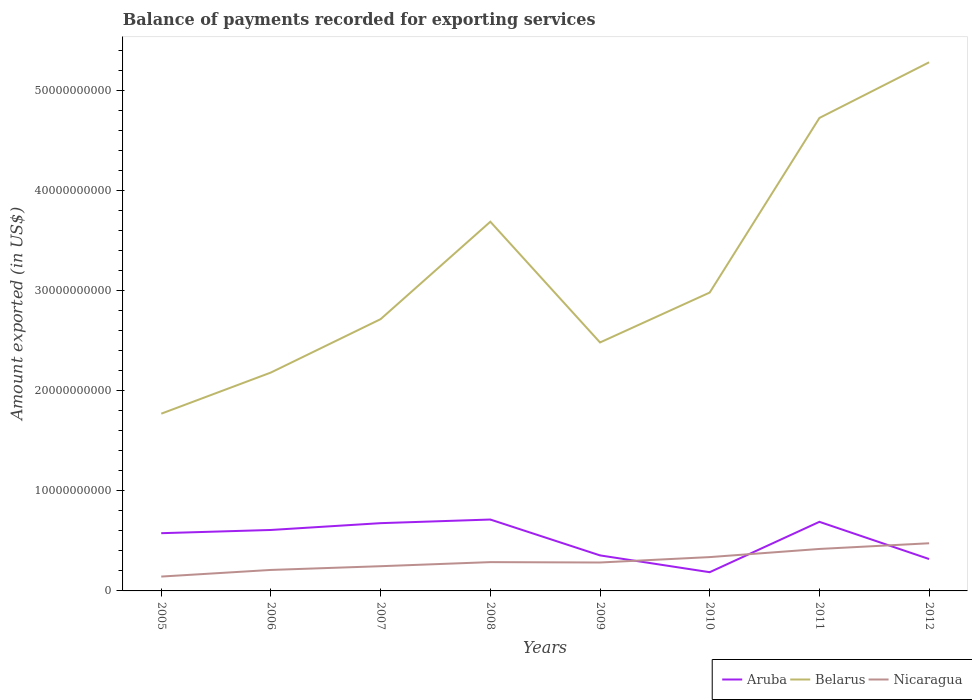How many different coloured lines are there?
Provide a short and direct response. 3. Does the line corresponding to Aruba intersect with the line corresponding to Nicaragua?
Ensure brevity in your answer.  Yes. Across all years, what is the maximum amount exported in Aruba?
Offer a terse response. 1.87e+09. What is the total amount exported in Nicaragua in the graph?
Offer a terse response. -1.35e+09. What is the difference between the highest and the second highest amount exported in Belarus?
Provide a short and direct response. 3.51e+1. What is the difference between the highest and the lowest amount exported in Nicaragua?
Ensure brevity in your answer.  3. How many years are there in the graph?
Provide a short and direct response. 8. Are the values on the major ticks of Y-axis written in scientific E-notation?
Keep it short and to the point. No. Does the graph contain any zero values?
Offer a very short reply. No. Does the graph contain grids?
Offer a very short reply. No. How are the legend labels stacked?
Ensure brevity in your answer.  Horizontal. What is the title of the graph?
Your response must be concise. Balance of payments recorded for exporting services. What is the label or title of the X-axis?
Your response must be concise. Years. What is the label or title of the Y-axis?
Your answer should be compact. Amount exported (in US$). What is the Amount exported (in US$) of Aruba in 2005?
Your answer should be very brief. 5.77e+09. What is the Amount exported (in US$) of Belarus in 2005?
Make the answer very short. 1.77e+1. What is the Amount exported (in US$) in Nicaragua in 2005?
Make the answer very short. 1.43e+09. What is the Amount exported (in US$) in Aruba in 2006?
Provide a succinct answer. 6.09e+09. What is the Amount exported (in US$) in Belarus in 2006?
Ensure brevity in your answer.  2.18e+1. What is the Amount exported (in US$) in Nicaragua in 2006?
Keep it short and to the point. 2.10e+09. What is the Amount exported (in US$) of Aruba in 2007?
Provide a succinct answer. 6.77e+09. What is the Amount exported (in US$) in Belarus in 2007?
Provide a short and direct response. 2.71e+1. What is the Amount exported (in US$) of Nicaragua in 2007?
Give a very brief answer. 2.47e+09. What is the Amount exported (in US$) of Aruba in 2008?
Ensure brevity in your answer.  7.13e+09. What is the Amount exported (in US$) in Belarus in 2008?
Your response must be concise. 3.69e+1. What is the Amount exported (in US$) in Nicaragua in 2008?
Keep it short and to the point. 2.88e+09. What is the Amount exported (in US$) in Aruba in 2009?
Ensure brevity in your answer.  3.55e+09. What is the Amount exported (in US$) of Belarus in 2009?
Ensure brevity in your answer.  2.48e+1. What is the Amount exported (in US$) in Nicaragua in 2009?
Provide a short and direct response. 2.84e+09. What is the Amount exported (in US$) in Aruba in 2010?
Keep it short and to the point. 1.87e+09. What is the Amount exported (in US$) in Belarus in 2010?
Your answer should be very brief. 2.98e+1. What is the Amount exported (in US$) in Nicaragua in 2010?
Your answer should be compact. 3.38e+09. What is the Amount exported (in US$) in Aruba in 2011?
Your answer should be very brief. 6.90e+09. What is the Amount exported (in US$) in Belarus in 2011?
Provide a short and direct response. 4.72e+1. What is the Amount exported (in US$) in Nicaragua in 2011?
Keep it short and to the point. 4.19e+09. What is the Amount exported (in US$) in Aruba in 2012?
Provide a succinct answer. 3.19e+09. What is the Amount exported (in US$) of Belarus in 2012?
Provide a succinct answer. 5.28e+1. What is the Amount exported (in US$) in Nicaragua in 2012?
Keep it short and to the point. 4.76e+09. Across all years, what is the maximum Amount exported (in US$) in Aruba?
Give a very brief answer. 7.13e+09. Across all years, what is the maximum Amount exported (in US$) in Belarus?
Ensure brevity in your answer.  5.28e+1. Across all years, what is the maximum Amount exported (in US$) of Nicaragua?
Offer a terse response. 4.76e+09. Across all years, what is the minimum Amount exported (in US$) in Aruba?
Give a very brief answer. 1.87e+09. Across all years, what is the minimum Amount exported (in US$) in Belarus?
Offer a very short reply. 1.77e+1. Across all years, what is the minimum Amount exported (in US$) in Nicaragua?
Offer a very short reply. 1.43e+09. What is the total Amount exported (in US$) in Aruba in the graph?
Provide a short and direct response. 4.13e+1. What is the total Amount exported (in US$) in Belarus in the graph?
Keep it short and to the point. 2.58e+11. What is the total Amount exported (in US$) of Nicaragua in the graph?
Your answer should be very brief. 2.40e+1. What is the difference between the Amount exported (in US$) of Aruba in 2005 and that in 2006?
Provide a short and direct response. -3.22e+08. What is the difference between the Amount exported (in US$) in Belarus in 2005 and that in 2006?
Make the answer very short. -4.11e+09. What is the difference between the Amount exported (in US$) in Nicaragua in 2005 and that in 2006?
Offer a terse response. -6.63e+08. What is the difference between the Amount exported (in US$) of Aruba in 2005 and that in 2007?
Your answer should be compact. -1.00e+09. What is the difference between the Amount exported (in US$) of Belarus in 2005 and that in 2007?
Offer a very short reply. -9.44e+09. What is the difference between the Amount exported (in US$) of Nicaragua in 2005 and that in 2007?
Provide a succinct answer. -1.04e+09. What is the difference between the Amount exported (in US$) of Aruba in 2005 and that in 2008?
Make the answer very short. -1.37e+09. What is the difference between the Amount exported (in US$) in Belarus in 2005 and that in 2008?
Provide a succinct answer. -1.92e+1. What is the difference between the Amount exported (in US$) of Nicaragua in 2005 and that in 2008?
Keep it short and to the point. -1.44e+09. What is the difference between the Amount exported (in US$) of Aruba in 2005 and that in 2009?
Give a very brief answer. 2.22e+09. What is the difference between the Amount exported (in US$) of Belarus in 2005 and that in 2009?
Ensure brevity in your answer.  -7.11e+09. What is the difference between the Amount exported (in US$) in Nicaragua in 2005 and that in 2009?
Offer a very short reply. -1.40e+09. What is the difference between the Amount exported (in US$) of Aruba in 2005 and that in 2010?
Provide a short and direct response. 3.90e+09. What is the difference between the Amount exported (in US$) in Belarus in 2005 and that in 2010?
Ensure brevity in your answer.  -1.21e+1. What is the difference between the Amount exported (in US$) in Nicaragua in 2005 and that in 2010?
Your response must be concise. -1.94e+09. What is the difference between the Amount exported (in US$) in Aruba in 2005 and that in 2011?
Make the answer very short. -1.14e+09. What is the difference between the Amount exported (in US$) in Belarus in 2005 and that in 2011?
Provide a short and direct response. -2.95e+1. What is the difference between the Amount exported (in US$) of Nicaragua in 2005 and that in 2011?
Give a very brief answer. -2.76e+09. What is the difference between the Amount exported (in US$) of Aruba in 2005 and that in 2012?
Your answer should be compact. 2.58e+09. What is the difference between the Amount exported (in US$) in Belarus in 2005 and that in 2012?
Offer a very short reply. -3.51e+1. What is the difference between the Amount exported (in US$) of Nicaragua in 2005 and that in 2012?
Make the answer very short. -3.33e+09. What is the difference between the Amount exported (in US$) of Aruba in 2006 and that in 2007?
Your answer should be very brief. -6.80e+08. What is the difference between the Amount exported (in US$) in Belarus in 2006 and that in 2007?
Keep it short and to the point. -5.33e+09. What is the difference between the Amount exported (in US$) of Nicaragua in 2006 and that in 2007?
Ensure brevity in your answer.  -3.72e+08. What is the difference between the Amount exported (in US$) of Aruba in 2006 and that in 2008?
Keep it short and to the point. -1.04e+09. What is the difference between the Amount exported (in US$) of Belarus in 2006 and that in 2008?
Provide a short and direct response. -1.51e+1. What is the difference between the Amount exported (in US$) of Nicaragua in 2006 and that in 2008?
Provide a short and direct response. -7.79e+08. What is the difference between the Amount exported (in US$) of Aruba in 2006 and that in 2009?
Provide a short and direct response. 2.54e+09. What is the difference between the Amount exported (in US$) of Belarus in 2006 and that in 2009?
Provide a short and direct response. -3.00e+09. What is the difference between the Amount exported (in US$) in Nicaragua in 2006 and that in 2009?
Your answer should be very brief. -7.42e+08. What is the difference between the Amount exported (in US$) of Aruba in 2006 and that in 2010?
Keep it short and to the point. 4.22e+09. What is the difference between the Amount exported (in US$) in Belarus in 2006 and that in 2010?
Give a very brief answer. -7.99e+09. What is the difference between the Amount exported (in US$) of Nicaragua in 2006 and that in 2010?
Provide a succinct answer. -1.28e+09. What is the difference between the Amount exported (in US$) in Aruba in 2006 and that in 2011?
Make the answer very short. -8.13e+08. What is the difference between the Amount exported (in US$) in Belarus in 2006 and that in 2011?
Offer a terse response. -2.54e+1. What is the difference between the Amount exported (in US$) in Nicaragua in 2006 and that in 2011?
Give a very brief answer. -2.09e+09. What is the difference between the Amount exported (in US$) of Aruba in 2006 and that in 2012?
Your response must be concise. 2.90e+09. What is the difference between the Amount exported (in US$) of Belarus in 2006 and that in 2012?
Your response must be concise. -3.10e+1. What is the difference between the Amount exported (in US$) in Nicaragua in 2006 and that in 2012?
Keep it short and to the point. -2.66e+09. What is the difference between the Amount exported (in US$) in Aruba in 2007 and that in 2008?
Keep it short and to the point. -3.63e+08. What is the difference between the Amount exported (in US$) in Belarus in 2007 and that in 2008?
Give a very brief answer. -9.73e+09. What is the difference between the Amount exported (in US$) in Nicaragua in 2007 and that in 2008?
Ensure brevity in your answer.  -4.07e+08. What is the difference between the Amount exported (in US$) of Aruba in 2007 and that in 2009?
Make the answer very short. 3.22e+09. What is the difference between the Amount exported (in US$) of Belarus in 2007 and that in 2009?
Your answer should be very brief. 2.33e+09. What is the difference between the Amount exported (in US$) of Nicaragua in 2007 and that in 2009?
Keep it short and to the point. -3.69e+08. What is the difference between the Amount exported (in US$) of Aruba in 2007 and that in 2010?
Your response must be concise. 4.90e+09. What is the difference between the Amount exported (in US$) of Belarus in 2007 and that in 2010?
Your response must be concise. -2.66e+09. What is the difference between the Amount exported (in US$) of Nicaragua in 2007 and that in 2010?
Provide a short and direct response. -9.09e+08. What is the difference between the Amount exported (in US$) in Aruba in 2007 and that in 2011?
Provide a short and direct response. -1.33e+08. What is the difference between the Amount exported (in US$) in Belarus in 2007 and that in 2011?
Make the answer very short. -2.01e+1. What is the difference between the Amount exported (in US$) of Nicaragua in 2007 and that in 2011?
Provide a succinct answer. -1.72e+09. What is the difference between the Amount exported (in US$) in Aruba in 2007 and that in 2012?
Provide a short and direct response. 3.58e+09. What is the difference between the Amount exported (in US$) of Belarus in 2007 and that in 2012?
Your answer should be very brief. -2.57e+1. What is the difference between the Amount exported (in US$) in Nicaragua in 2007 and that in 2012?
Offer a terse response. -2.29e+09. What is the difference between the Amount exported (in US$) in Aruba in 2008 and that in 2009?
Ensure brevity in your answer.  3.58e+09. What is the difference between the Amount exported (in US$) in Belarus in 2008 and that in 2009?
Ensure brevity in your answer.  1.21e+1. What is the difference between the Amount exported (in US$) of Nicaragua in 2008 and that in 2009?
Give a very brief answer. 3.75e+07. What is the difference between the Amount exported (in US$) of Aruba in 2008 and that in 2010?
Make the answer very short. 5.26e+09. What is the difference between the Amount exported (in US$) of Belarus in 2008 and that in 2010?
Offer a very short reply. 7.07e+09. What is the difference between the Amount exported (in US$) in Nicaragua in 2008 and that in 2010?
Your response must be concise. -5.02e+08. What is the difference between the Amount exported (in US$) in Aruba in 2008 and that in 2011?
Provide a succinct answer. 2.30e+08. What is the difference between the Amount exported (in US$) of Belarus in 2008 and that in 2011?
Offer a very short reply. -1.04e+1. What is the difference between the Amount exported (in US$) of Nicaragua in 2008 and that in 2011?
Provide a succinct answer. -1.32e+09. What is the difference between the Amount exported (in US$) in Aruba in 2008 and that in 2012?
Give a very brief answer. 3.95e+09. What is the difference between the Amount exported (in US$) of Belarus in 2008 and that in 2012?
Make the answer very short. -1.59e+1. What is the difference between the Amount exported (in US$) of Nicaragua in 2008 and that in 2012?
Your answer should be very brief. -1.88e+09. What is the difference between the Amount exported (in US$) in Aruba in 2009 and that in 2010?
Offer a very short reply. 1.68e+09. What is the difference between the Amount exported (in US$) in Belarus in 2009 and that in 2010?
Your response must be concise. -4.99e+09. What is the difference between the Amount exported (in US$) in Nicaragua in 2009 and that in 2010?
Your answer should be compact. -5.40e+08. What is the difference between the Amount exported (in US$) in Aruba in 2009 and that in 2011?
Your answer should be very brief. -3.35e+09. What is the difference between the Amount exported (in US$) of Belarus in 2009 and that in 2011?
Offer a very short reply. -2.24e+1. What is the difference between the Amount exported (in US$) in Nicaragua in 2009 and that in 2011?
Your answer should be very brief. -1.35e+09. What is the difference between the Amount exported (in US$) of Aruba in 2009 and that in 2012?
Your answer should be compact. 3.63e+08. What is the difference between the Amount exported (in US$) of Belarus in 2009 and that in 2012?
Keep it short and to the point. -2.80e+1. What is the difference between the Amount exported (in US$) of Nicaragua in 2009 and that in 2012?
Your response must be concise. -1.92e+09. What is the difference between the Amount exported (in US$) of Aruba in 2010 and that in 2011?
Give a very brief answer. -5.03e+09. What is the difference between the Amount exported (in US$) in Belarus in 2010 and that in 2011?
Provide a succinct answer. -1.74e+1. What is the difference between the Amount exported (in US$) of Nicaragua in 2010 and that in 2011?
Provide a succinct answer. -8.13e+08. What is the difference between the Amount exported (in US$) of Aruba in 2010 and that in 2012?
Keep it short and to the point. -1.32e+09. What is the difference between the Amount exported (in US$) in Belarus in 2010 and that in 2012?
Ensure brevity in your answer.  -2.30e+1. What is the difference between the Amount exported (in US$) in Nicaragua in 2010 and that in 2012?
Give a very brief answer. -1.38e+09. What is the difference between the Amount exported (in US$) in Aruba in 2011 and that in 2012?
Offer a terse response. 3.72e+09. What is the difference between the Amount exported (in US$) of Belarus in 2011 and that in 2012?
Your response must be concise. -5.56e+09. What is the difference between the Amount exported (in US$) in Nicaragua in 2011 and that in 2012?
Offer a very short reply. -5.69e+08. What is the difference between the Amount exported (in US$) of Aruba in 2005 and the Amount exported (in US$) of Belarus in 2006?
Your answer should be very brief. -1.60e+1. What is the difference between the Amount exported (in US$) in Aruba in 2005 and the Amount exported (in US$) in Nicaragua in 2006?
Your response must be concise. 3.67e+09. What is the difference between the Amount exported (in US$) of Belarus in 2005 and the Amount exported (in US$) of Nicaragua in 2006?
Your response must be concise. 1.56e+1. What is the difference between the Amount exported (in US$) of Aruba in 2005 and the Amount exported (in US$) of Belarus in 2007?
Make the answer very short. -2.14e+1. What is the difference between the Amount exported (in US$) in Aruba in 2005 and the Amount exported (in US$) in Nicaragua in 2007?
Your answer should be compact. 3.30e+09. What is the difference between the Amount exported (in US$) of Belarus in 2005 and the Amount exported (in US$) of Nicaragua in 2007?
Give a very brief answer. 1.52e+1. What is the difference between the Amount exported (in US$) in Aruba in 2005 and the Amount exported (in US$) in Belarus in 2008?
Your answer should be compact. -3.11e+1. What is the difference between the Amount exported (in US$) of Aruba in 2005 and the Amount exported (in US$) of Nicaragua in 2008?
Provide a succinct answer. 2.89e+09. What is the difference between the Amount exported (in US$) of Belarus in 2005 and the Amount exported (in US$) of Nicaragua in 2008?
Your answer should be very brief. 1.48e+1. What is the difference between the Amount exported (in US$) in Aruba in 2005 and the Amount exported (in US$) in Belarus in 2009?
Provide a short and direct response. -1.91e+1. What is the difference between the Amount exported (in US$) of Aruba in 2005 and the Amount exported (in US$) of Nicaragua in 2009?
Your response must be concise. 2.93e+09. What is the difference between the Amount exported (in US$) of Belarus in 2005 and the Amount exported (in US$) of Nicaragua in 2009?
Your answer should be compact. 1.49e+1. What is the difference between the Amount exported (in US$) of Aruba in 2005 and the Amount exported (in US$) of Belarus in 2010?
Offer a very short reply. -2.40e+1. What is the difference between the Amount exported (in US$) in Aruba in 2005 and the Amount exported (in US$) in Nicaragua in 2010?
Your response must be concise. 2.39e+09. What is the difference between the Amount exported (in US$) of Belarus in 2005 and the Amount exported (in US$) of Nicaragua in 2010?
Keep it short and to the point. 1.43e+1. What is the difference between the Amount exported (in US$) of Aruba in 2005 and the Amount exported (in US$) of Belarus in 2011?
Provide a succinct answer. -4.15e+1. What is the difference between the Amount exported (in US$) in Aruba in 2005 and the Amount exported (in US$) in Nicaragua in 2011?
Your response must be concise. 1.57e+09. What is the difference between the Amount exported (in US$) of Belarus in 2005 and the Amount exported (in US$) of Nicaragua in 2011?
Provide a short and direct response. 1.35e+1. What is the difference between the Amount exported (in US$) of Aruba in 2005 and the Amount exported (in US$) of Belarus in 2012?
Ensure brevity in your answer.  -4.70e+1. What is the difference between the Amount exported (in US$) of Aruba in 2005 and the Amount exported (in US$) of Nicaragua in 2012?
Provide a short and direct response. 1.01e+09. What is the difference between the Amount exported (in US$) in Belarus in 2005 and the Amount exported (in US$) in Nicaragua in 2012?
Give a very brief answer. 1.29e+1. What is the difference between the Amount exported (in US$) in Aruba in 2006 and the Amount exported (in US$) in Belarus in 2007?
Ensure brevity in your answer.  -2.11e+1. What is the difference between the Amount exported (in US$) in Aruba in 2006 and the Amount exported (in US$) in Nicaragua in 2007?
Offer a terse response. 3.62e+09. What is the difference between the Amount exported (in US$) of Belarus in 2006 and the Amount exported (in US$) of Nicaragua in 2007?
Your response must be concise. 1.93e+1. What is the difference between the Amount exported (in US$) of Aruba in 2006 and the Amount exported (in US$) of Belarus in 2008?
Keep it short and to the point. -3.08e+1. What is the difference between the Amount exported (in US$) in Aruba in 2006 and the Amount exported (in US$) in Nicaragua in 2008?
Make the answer very short. 3.21e+09. What is the difference between the Amount exported (in US$) of Belarus in 2006 and the Amount exported (in US$) of Nicaragua in 2008?
Offer a terse response. 1.89e+1. What is the difference between the Amount exported (in US$) of Aruba in 2006 and the Amount exported (in US$) of Belarus in 2009?
Keep it short and to the point. -1.87e+1. What is the difference between the Amount exported (in US$) of Aruba in 2006 and the Amount exported (in US$) of Nicaragua in 2009?
Your answer should be very brief. 3.25e+09. What is the difference between the Amount exported (in US$) of Belarus in 2006 and the Amount exported (in US$) of Nicaragua in 2009?
Offer a terse response. 1.90e+1. What is the difference between the Amount exported (in US$) of Aruba in 2006 and the Amount exported (in US$) of Belarus in 2010?
Make the answer very short. -2.37e+1. What is the difference between the Amount exported (in US$) of Aruba in 2006 and the Amount exported (in US$) of Nicaragua in 2010?
Your answer should be very brief. 2.71e+09. What is the difference between the Amount exported (in US$) of Belarus in 2006 and the Amount exported (in US$) of Nicaragua in 2010?
Offer a terse response. 1.84e+1. What is the difference between the Amount exported (in US$) of Aruba in 2006 and the Amount exported (in US$) of Belarus in 2011?
Provide a short and direct response. -4.12e+1. What is the difference between the Amount exported (in US$) in Aruba in 2006 and the Amount exported (in US$) in Nicaragua in 2011?
Ensure brevity in your answer.  1.90e+09. What is the difference between the Amount exported (in US$) of Belarus in 2006 and the Amount exported (in US$) of Nicaragua in 2011?
Your answer should be very brief. 1.76e+1. What is the difference between the Amount exported (in US$) of Aruba in 2006 and the Amount exported (in US$) of Belarus in 2012?
Ensure brevity in your answer.  -4.67e+1. What is the difference between the Amount exported (in US$) of Aruba in 2006 and the Amount exported (in US$) of Nicaragua in 2012?
Offer a terse response. 1.33e+09. What is the difference between the Amount exported (in US$) in Belarus in 2006 and the Amount exported (in US$) in Nicaragua in 2012?
Offer a very short reply. 1.71e+1. What is the difference between the Amount exported (in US$) in Aruba in 2007 and the Amount exported (in US$) in Belarus in 2008?
Make the answer very short. -3.01e+1. What is the difference between the Amount exported (in US$) of Aruba in 2007 and the Amount exported (in US$) of Nicaragua in 2008?
Offer a very short reply. 3.89e+09. What is the difference between the Amount exported (in US$) in Belarus in 2007 and the Amount exported (in US$) in Nicaragua in 2008?
Make the answer very short. 2.43e+1. What is the difference between the Amount exported (in US$) of Aruba in 2007 and the Amount exported (in US$) of Belarus in 2009?
Keep it short and to the point. -1.80e+1. What is the difference between the Amount exported (in US$) in Aruba in 2007 and the Amount exported (in US$) in Nicaragua in 2009?
Provide a short and direct response. 3.93e+09. What is the difference between the Amount exported (in US$) of Belarus in 2007 and the Amount exported (in US$) of Nicaragua in 2009?
Keep it short and to the point. 2.43e+1. What is the difference between the Amount exported (in US$) in Aruba in 2007 and the Amount exported (in US$) in Belarus in 2010?
Provide a short and direct response. -2.30e+1. What is the difference between the Amount exported (in US$) of Aruba in 2007 and the Amount exported (in US$) of Nicaragua in 2010?
Ensure brevity in your answer.  3.39e+09. What is the difference between the Amount exported (in US$) of Belarus in 2007 and the Amount exported (in US$) of Nicaragua in 2010?
Keep it short and to the point. 2.38e+1. What is the difference between the Amount exported (in US$) of Aruba in 2007 and the Amount exported (in US$) of Belarus in 2011?
Your answer should be compact. -4.05e+1. What is the difference between the Amount exported (in US$) of Aruba in 2007 and the Amount exported (in US$) of Nicaragua in 2011?
Offer a very short reply. 2.58e+09. What is the difference between the Amount exported (in US$) in Belarus in 2007 and the Amount exported (in US$) in Nicaragua in 2011?
Make the answer very short. 2.30e+1. What is the difference between the Amount exported (in US$) of Aruba in 2007 and the Amount exported (in US$) of Belarus in 2012?
Offer a very short reply. -4.60e+1. What is the difference between the Amount exported (in US$) of Aruba in 2007 and the Amount exported (in US$) of Nicaragua in 2012?
Give a very brief answer. 2.01e+09. What is the difference between the Amount exported (in US$) in Belarus in 2007 and the Amount exported (in US$) in Nicaragua in 2012?
Provide a short and direct response. 2.24e+1. What is the difference between the Amount exported (in US$) in Aruba in 2008 and the Amount exported (in US$) in Belarus in 2009?
Make the answer very short. -1.77e+1. What is the difference between the Amount exported (in US$) in Aruba in 2008 and the Amount exported (in US$) in Nicaragua in 2009?
Give a very brief answer. 4.29e+09. What is the difference between the Amount exported (in US$) of Belarus in 2008 and the Amount exported (in US$) of Nicaragua in 2009?
Keep it short and to the point. 3.40e+1. What is the difference between the Amount exported (in US$) of Aruba in 2008 and the Amount exported (in US$) of Belarus in 2010?
Provide a short and direct response. -2.27e+1. What is the difference between the Amount exported (in US$) in Aruba in 2008 and the Amount exported (in US$) in Nicaragua in 2010?
Give a very brief answer. 3.75e+09. What is the difference between the Amount exported (in US$) of Belarus in 2008 and the Amount exported (in US$) of Nicaragua in 2010?
Offer a terse response. 3.35e+1. What is the difference between the Amount exported (in US$) of Aruba in 2008 and the Amount exported (in US$) of Belarus in 2011?
Make the answer very short. -4.01e+1. What is the difference between the Amount exported (in US$) of Aruba in 2008 and the Amount exported (in US$) of Nicaragua in 2011?
Make the answer very short. 2.94e+09. What is the difference between the Amount exported (in US$) of Belarus in 2008 and the Amount exported (in US$) of Nicaragua in 2011?
Your answer should be compact. 3.27e+1. What is the difference between the Amount exported (in US$) in Aruba in 2008 and the Amount exported (in US$) in Belarus in 2012?
Keep it short and to the point. -4.57e+1. What is the difference between the Amount exported (in US$) of Aruba in 2008 and the Amount exported (in US$) of Nicaragua in 2012?
Provide a short and direct response. 2.37e+09. What is the difference between the Amount exported (in US$) in Belarus in 2008 and the Amount exported (in US$) in Nicaragua in 2012?
Your response must be concise. 3.21e+1. What is the difference between the Amount exported (in US$) in Aruba in 2009 and the Amount exported (in US$) in Belarus in 2010?
Provide a succinct answer. -2.63e+1. What is the difference between the Amount exported (in US$) of Aruba in 2009 and the Amount exported (in US$) of Nicaragua in 2010?
Provide a short and direct response. 1.71e+08. What is the difference between the Amount exported (in US$) of Belarus in 2009 and the Amount exported (in US$) of Nicaragua in 2010?
Offer a terse response. 2.14e+1. What is the difference between the Amount exported (in US$) of Aruba in 2009 and the Amount exported (in US$) of Belarus in 2011?
Provide a succinct answer. -4.37e+1. What is the difference between the Amount exported (in US$) of Aruba in 2009 and the Amount exported (in US$) of Nicaragua in 2011?
Your answer should be very brief. -6.42e+08. What is the difference between the Amount exported (in US$) in Belarus in 2009 and the Amount exported (in US$) in Nicaragua in 2011?
Your answer should be very brief. 2.06e+1. What is the difference between the Amount exported (in US$) in Aruba in 2009 and the Amount exported (in US$) in Belarus in 2012?
Make the answer very short. -4.93e+1. What is the difference between the Amount exported (in US$) in Aruba in 2009 and the Amount exported (in US$) in Nicaragua in 2012?
Provide a succinct answer. -1.21e+09. What is the difference between the Amount exported (in US$) in Belarus in 2009 and the Amount exported (in US$) in Nicaragua in 2012?
Provide a succinct answer. 2.01e+1. What is the difference between the Amount exported (in US$) of Aruba in 2010 and the Amount exported (in US$) of Belarus in 2011?
Offer a terse response. -4.54e+1. What is the difference between the Amount exported (in US$) of Aruba in 2010 and the Amount exported (in US$) of Nicaragua in 2011?
Give a very brief answer. -2.32e+09. What is the difference between the Amount exported (in US$) of Belarus in 2010 and the Amount exported (in US$) of Nicaragua in 2011?
Keep it short and to the point. 2.56e+1. What is the difference between the Amount exported (in US$) of Aruba in 2010 and the Amount exported (in US$) of Belarus in 2012?
Keep it short and to the point. -5.09e+1. What is the difference between the Amount exported (in US$) in Aruba in 2010 and the Amount exported (in US$) in Nicaragua in 2012?
Ensure brevity in your answer.  -2.89e+09. What is the difference between the Amount exported (in US$) of Belarus in 2010 and the Amount exported (in US$) of Nicaragua in 2012?
Your answer should be compact. 2.50e+1. What is the difference between the Amount exported (in US$) in Aruba in 2011 and the Amount exported (in US$) in Belarus in 2012?
Keep it short and to the point. -4.59e+1. What is the difference between the Amount exported (in US$) of Aruba in 2011 and the Amount exported (in US$) of Nicaragua in 2012?
Provide a short and direct response. 2.14e+09. What is the difference between the Amount exported (in US$) in Belarus in 2011 and the Amount exported (in US$) in Nicaragua in 2012?
Your answer should be compact. 4.25e+1. What is the average Amount exported (in US$) in Aruba per year?
Make the answer very short. 5.16e+09. What is the average Amount exported (in US$) of Belarus per year?
Offer a very short reply. 3.23e+1. What is the average Amount exported (in US$) in Nicaragua per year?
Provide a succinct answer. 3.01e+09. In the year 2005, what is the difference between the Amount exported (in US$) of Aruba and Amount exported (in US$) of Belarus?
Your answer should be compact. -1.19e+1. In the year 2005, what is the difference between the Amount exported (in US$) in Aruba and Amount exported (in US$) in Nicaragua?
Your response must be concise. 4.33e+09. In the year 2005, what is the difference between the Amount exported (in US$) of Belarus and Amount exported (in US$) of Nicaragua?
Offer a terse response. 1.63e+1. In the year 2006, what is the difference between the Amount exported (in US$) in Aruba and Amount exported (in US$) in Belarus?
Your answer should be very brief. -1.57e+1. In the year 2006, what is the difference between the Amount exported (in US$) in Aruba and Amount exported (in US$) in Nicaragua?
Offer a very short reply. 3.99e+09. In the year 2006, what is the difference between the Amount exported (in US$) of Belarus and Amount exported (in US$) of Nicaragua?
Give a very brief answer. 1.97e+1. In the year 2007, what is the difference between the Amount exported (in US$) in Aruba and Amount exported (in US$) in Belarus?
Ensure brevity in your answer.  -2.04e+1. In the year 2007, what is the difference between the Amount exported (in US$) in Aruba and Amount exported (in US$) in Nicaragua?
Provide a short and direct response. 4.30e+09. In the year 2007, what is the difference between the Amount exported (in US$) of Belarus and Amount exported (in US$) of Nicaragua?
Ensure brevity in your answer.  2.47e+1. In the year 2008, what is the difference between the Amount exported (in US$) in Aruba and Amount exported (in US$) in Belarus?
Give a very brief answer. -2.97e+1. In the year 2008, what is the difference between the Amount exported (in US$) of Aruba and Amount exported (in US$) of Nicaragua?
Offer a very short reply. 4.26e+09. In the year 2008, what is the difference between the Amount exported (in US$) of Belarus and Amount exported (in US$) of Nicaragua?
Make the answer very short. 3.40e+1. In the year 2009, what is the difference between the Amount exported (in US$) in Aruba and Amount exported (in US$) in Belarus?
Make the answer very short. -2.13e+1. In the year 2009, what is the difference between the Amount exported (in US$) of Aruba and Amount exported (in US$) of Nicaragua?
Keep it short and to the point. 7.11e+08. In the year 2009, what is the difference between the Amount exported (in US$) of Belarus and Amount exported (in US$) of Nicaragua?
Provide a succinct answer. 2.20e+1. In the year 2010, what is the difference between the Amount exported (in US$) of Aruba and Amount exported (in US$) of Belarus?
Keep it short and to the point. -2.79e+1. In the year 2010, what is the difference between the Amount exported (in US$) in Aruba and Amount exported (in US$) in Nicaragua?
Offer a very short reply. -1.51e+09. In the year 2010, what is the difference between the Amount exported (in US$) in Belarus and Amount exported (in US$) in Nicaragua?
Your answer should be very brief. 2.64e+1. In the year 2011, what is the difference between the Amount exported (in US$) of Aruba and Amount exported (in US$) of Belarus?
Offer a very short reply. -4.03e+1. In the year 2011, what is the difference between the Amount exported (in US$) of Aruba and Amount exported (in US$) of Nicaragua?
Offer a very short reply. 2.71e+09. In the year 2011, what is the difference between the Amount exported (in US$) of Belarus and Amount exported (in US$) of Nicaragua?
Your answer should be compact. 4.31e+1. In the year 2012, what is the difference between the Amount exported (in US$) in Aruba and Amount exported (in US$) in Belarus?
Keep it short and to the point. -4.96e+1. In the year 2012, what is the difference between the Amount exported (in US$) in Aruba and Amount exported (in US$) in Nicaragua?
Provide a short and direct response. -1.57e+09. In the year 2012, what is the difference between the Amount exported (in US$) of Belarus and Amount exported (in US$) of Nicaragua?
Your answer should be very brief. 4.80e+1. What is the ratio of the Amount exported (in US$) of Aruba in 2005 to that in 2006?
Give a very brief answer. 0.95. What is the ratio of the Amount exported (in US$) in Belarus in 2005 to that in 2006?
Provide a succinct answer. 0.81. What is the ratio of the Amount exported (in US$) in Nicaragua in 2005 to that in 2006?
Offer a very short reply. 0.68. What is the ratio of the Amount exported (in US$) of Aruba in 2005 to that in 2007?
Offer a terse response. 0.85. What is the ratio of the Amount exported (in US$) in Belarus in 2005 to that in 2007?
Your answer should be very brief. 0.65. What is the ratio of the Amount exported (in US$) in Nicaragua in 2005 to that in 2007?
Keep it short and to the point. 0.58. What is the ratio of the Amount exported (in US$) of Aruba in 2005 to that in 2008?
Make the answer very short. 0.81. What is the ratio of the Amount exported (in US$) in Belarus in 2005 to that in 2008?
Give a very brief answer. 0.48. What is the ratio of the Amount exported (in US$) in Nicaragua in 2005 to that in 2008?
Ensure brevity in your answer.  0.5. What is the ratio of the Amount exported (in US$) of Aruba in 2005 to that in 2009?
Your answer should be very brief. 1.62. What is the ratio of the Amount exported (in US$) in Belarus in 2005 to that in 2009?
Give a very brief answer. 0.71. What is the ratio of the Amount exported (in US$) in Nicaragua in 2005 to that in 2009?
Your answer should be very brief. 0.51. What is the ratio of the Amount exported (in US$) of Aruba in 2005 to that in 2010?
Offer a terse response. 3.08. What is the ratio of the Amount exported (in US$) in Belarus in 2005 to that in 2010?
Provide a succinct answer. 0.59. What is the ratio of the Amount exported (in US$) of Nicaragua in 2005 to that in 2010?
Offer a very short reply. 0.42. What is the ratio of the Amount exported (in US$) in Aruba in 2005 to that in 2011?
Provide a succinct answer. 0.84. What is the ratio of the Amount exported (in US$) in Belarus in 2005 to that in 2011?
Provide a short and direct response. 0.37. What is the ratio of the Amount exported (in US$) of Nicaragua in 2005 to that in 2011?
Keep it short and to the point. 0.34. What is the ratio of the Amount exported (in US$) of Aruba in 2005 to that in 2012?
Provide a succinct answer. 1.81. What is the ratio of the Amount exported (in US$) of Belarus in 2005 to that in 2012?
Your response must be concise. 0.34. What is the ratio of the Amount exported (in US$) in Nicaragua in 2005 to that in 2012?
Your answer should be compact. 0.3. What is the ratio of the Amount exported (in US$) of Aruba in 2006 to that in 2007?
Your answer should be compact. 0.9. What is the ratio of the Amount exported (in US$) in Belarus in 2006 to that in 2007?
Give a very brief answer. 0.8. What is the ratio of the Amount exported (in US$) in Nicaragua in 2006 to that in 2007?
Your answer should be very brief. 0.85. What is the ratio of the Amount exported (in US$) in Aruba in 2006 to that in 2008?
Provide a succinct answer. 0.85. What is the ratio of the Amount exported (in US$) of Belarus in 2006 to that in 2008?
Keep it short and to the point. 0.59. What is the ratio of the Amount exported (in US$) of Nicaragua in 2006 to that in 2008?
Offer a terse response. 0.73. What is the ratio of the Amount exported (in US$) in Aruba in 2006 to that in 2009?
Keep it short and to the point. 1.72. What is the ratio of the Amount exported (in US$) of Belarus in 2006 to that in 2009?
Offer a very short reply. 0.88. What is the ratio of the Amount exported (in US$) of Nicaragua in 2006 to that in 2009?
Provide a succinct answer. 0.74. What is the ratio of the Amount exported (in US$) in Aruba in 2006 to that in 2010?
Keep it short and to the point. 3.25. What is the ratio of the Amount exported (in US$) in Belarus in 2006 to that in 2010?
Ensure brevity in your answer.  0.73. What is the ratio of the Amount exported (in US$) in Nicaragua in 2006 to that in 2010?
Provide a succinct answer. 0.62. What is the ratio of the Amount exported (in US$) in Aruba in 2006 to that in 2011?
Offer a very short reply. 0.88. What is the ratio of the Amount exported (in US$) of Belarus in 2006 to that in 2011?
Provide a succinct answer. 0.46. What is the ratio of the Amount exported (in US$) in Nicaragua in 2006 to that in 2011?
Your answer should be compact. 0.5. What is the ratio of the Amount exported (in US$) of Aruba in 2006 to that in 2012?
Your answer should be very brief. 1.91. What is the ratio of the Amount exported (in US$) of Belarus in 2006 to that in 2012?
Provide a succinct answer. 0.41. What is the ratio of the Amount exported (in US$) in Nicaragua in 2006 to that in 2012?
Provide a succinct answer. 0.44. What is the ratio of the Amount exported (in US$) in Aruba in 2007 to that in 2008?
Your response must be concise. 0.95. What is the ratio of the Amount exported (in US$) in Belarus in 2007 to that in 2008?
Make the answer very short. 0.74. What is the ratio of the Amount exported (in US$) in Nicaragua in 2007 to that in 2008?
Give a very brief answer. 0.86. What is the ratio of the Amount exported (in US$) of Aruba in 2007 to that in 2009?
Offer a terse response. 1.91. What is the ratio of the Amount exported (in US$) in Belarus in 2007 to that in 2009?
Offer a terse response. 1.09. What is the ratio of the Amount exported (in US$) of Nicaragua in 2007 to that in 2009?
Provide a short and direct response. 0.87. What is the ratio of the Amount exported (in US$) in Aruba in 2007 to that in 2010?
Your answer should be compact. 3.62. What is the ratio of the Amount exported (in US$) of Belarus in 2007 to that in 2010?
Your answer should be compact. 0.91. What is the ratio of the Amount exported (in US$) of Nicaragua in 2007 to that in 2010?
Your answer should be compact. 0.73. What is the ratio of the Amount exported (in US$) of Aruba in 2007 to that in 2011?
Your answer should be very brief. 0.98. What is the ratio of the Amount exported (in US$) in Belarus in 2007 to that in 2011?
Your answer should be very brief. 0.57. What is the ratio of the Amount exported (in US$) in Nicaragua in 2007 to that in 2011?
Offer a very short reply. 0.59. What is the ratio of the Amount exported (in US$) of Aruba in 2007 to that in 2012?
Give a very brief answer. 2.12. What is the ratio of the Amount exported (in US$) in Belarus in 2007 to that in 2012?
Offer a very short reply. 0.51. What is the ratio of the Amount exported (in US$) in Nicaragua in 2007 to that in 2012?
Give a very brief answer. 0.52. What is the ratio of the Amount exported (in US$) in Aruba in 2008 to that in 2009?
Offer a very short reply. 2.01. What is the ratio of the Amount exported (in US$) in Belarus in 2008 to that in 2009?
Give a very brief answer. 1.49. What is the ratio of the Amount exported (in US$) in Nicaragua in 2008 to that in 2009?
Keep it short and to the point. 1.01. What is the ratio of the Amount exported (in US$) of Aruba in 2008 to that in 2010?
Your response must be concise. 3.81. What is the ratio of the Amount exported (in US$) of Belarus in 2008 to that in 2010?
Offer a terse response. 1.24. What is the ratio of the Amount exported (in US$) in Nicaragua in 2008 to that in 2010?
Your response must be concise. 0.85. What is the ratio of the Amount exported (in US$) in Belarus in 2008 to that in 2011?
Keep it short and to the point. 0.78. What is the ratio of the Amount exported (in US$) in Nicaragua in 2008 to that in 2011?
Make the answer very short. 0.69. What is the ratio of the Amount exported (in US$) in Aruba in 2008 to that in 2012?
Make the answer very short. 2.24. What is the ratio of the Amount exported (in US$) in Belarus in 2008 to that in 2012?
Your answer should be compact. 0.7. What is the ratio of the Amount exported (in US$) of Nicaragua in 2008 to that in 2012?
Your answer should be compact. 0.6. What is the ratio of the Amount exported (in US$) of Aruba in 2009 to that in 2010?
Ensure brevity in your answer.  1.9. What is the ratio of the Amount exported (in US$) of Belarus in 2009 to that in 2010?
Ensure brevity in your answer.  0.83. What is the ratio of the Amount exported (in US$) of Nicaragua in 2009 to that in 2010?
Provide a succinct answer. 0.84. What is the ratio of the Amount exported (in US$) of Aruba in 2009 to that in 2011?
Your response must be concise. 0.51. What is the ratio of the Amount exported (in US$) of Belarus in 2009 to that in 2011?
Ensure brevity in your answer.  0.53. What is the ratio of the Amount exported (in US$) in Nicaragua in 2009 to that in 2011?
Keep it short and to the point. 0.68. What is the ratio of the Amount exported (in US$) in Aruba in 2009 to that in 2012?
Your answer should be very brief. 1.11. What is the ratio of the Amount exported (in US$) of Belarus in 2009 to that in 2012?
Your response must be concise. 0.47. What is the ratio of the Amount exported (in US$) of Nicaragua in 2009 to that in 2012?
Ensure brevity in your answer.  0.6. What is the ratio of the Amount exported (in US$) of Aruba in 2010 to that in 2011?
Your answer should be compact. 0.27. What is the ratio of the Amount exported (in US$) of Belarus in 2010 to that in 2011?
Make the answer very short. 0.63. What is the ratio of the Amount exported (in US$) in Nicaragua in 2010 to that in 2011?
Ensure brevity in your answer.  0.81. What is the ratio of the Amount exported (in US$) of Aruba in 2010 to that in 2012?
Provide a succinct answer. 0.59. What is the ratio of the Amount exported (in US$) of Belarus in 2010 to that in 2012?
Offer a very short reply. 0.56. What is the ratio of the Amount exported (in US$) in Nicaragua in 2010 to that in 2012?
Provide a short and direct response. 0.71. What is the ratio of the Amount exported (in US$) of Aruba in 2011 to that in 2012?
Your answer should be very brief. 2.17. What is the ratio of the Amount exported (in US$) of Belarus in 2011 to that in 2012?
Your response must be concise. 0.89. What is the ratio of the Amount exported (in US$) of Nicaragua in 2011 to that in 2012?
Your answer should be very brief. 0.88. What is the difference between the highest and the second highest Amount exported (in US$) in Aruba?
Offer a very short reply. 2.30e+08. What is the difference between the highest and the second highest Amount exported (in US$) of Belarus?
Offer a terse response. 5.56e+09. What is the difference between the highest and the second highest Amount exported (in US$) in Nicaragua?
Provide a short and direct response. 5.69e+08. What is the difference between the highest and the lowest Amount exported (in US$) in Aruba?
Make the answer very short. 5.26e+09. What is the difference between the highest and the lowest Amount exported (in US$) in Belarus?
Keep it short and to the point. 3.51e+1. What is the difference between the highest and the lowest Amount exported (in US$) of Nicaragua?
Offer a very short reply. 3.33e+09. 